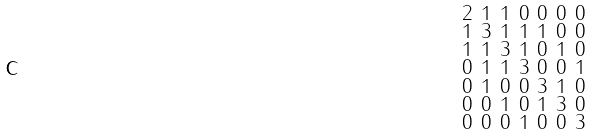Convert formula to latex. <formula><loc_0><loc_0><loc_500><loc_500>\begin{smallmatrix} 2 & 1 & 1 & 0 & 0 & 0 & 0 \\ 1 & 3 & 1 & 1 & 1 & 0 & 0 \\ 1 & 1 & 3 & 1 & 0 & 1 & 0 \\ 0 & 1 & 1 & 3 & 0 & 0 & 1 \\ 0 & 1 & 0 & 0 & 3 & 1 & 0 \\ 0 & 0 & 1 & 0 & 1 & 3 & 0 \\ 0 & 0 & 0 & 1 & 0 & 0 & 3 \end{smallmatrix}</formula> 